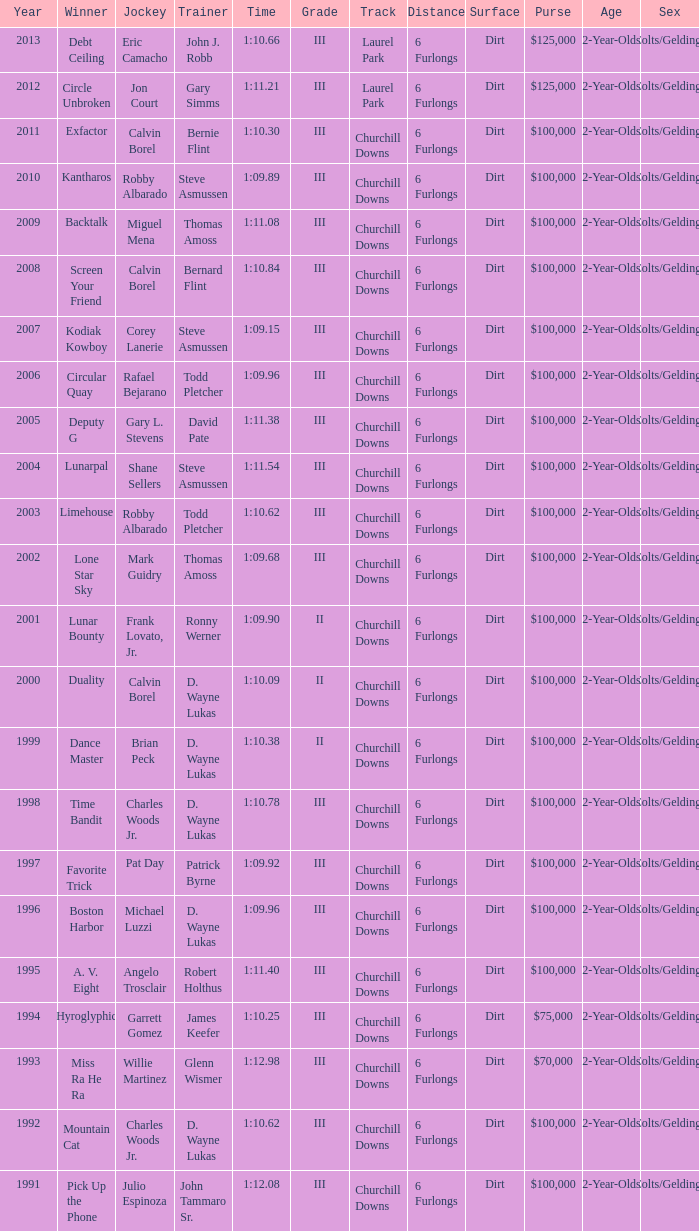How long did screen your friend last? 1:10.84. 